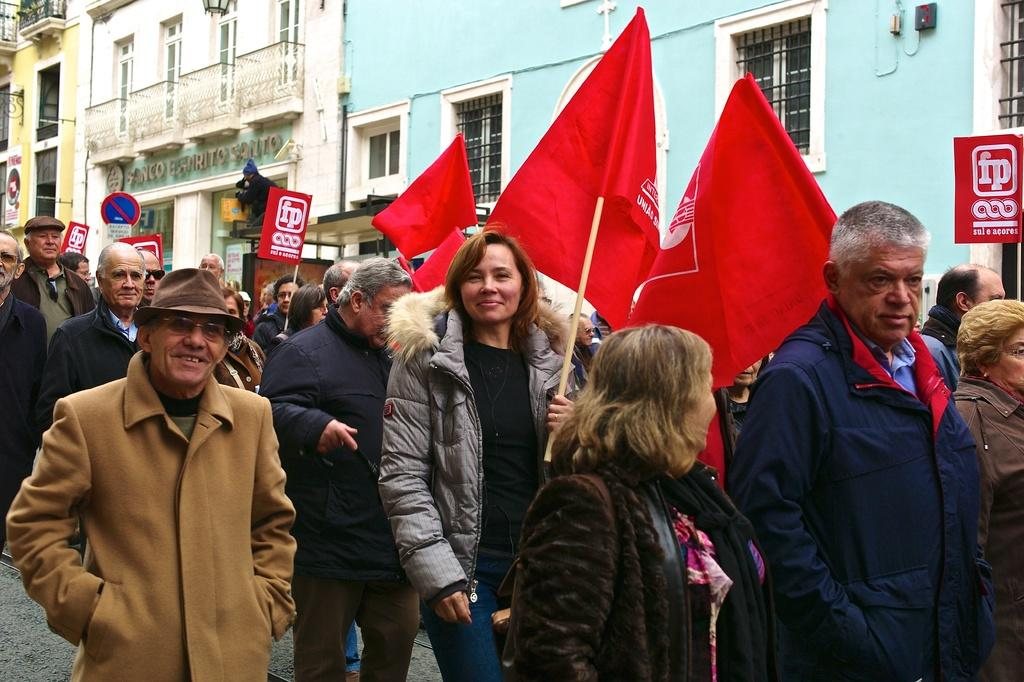What are the people in the image holding? The people in the image are holding flags and placards. What are the people doing in the image? The people are protesting on the street. What can be seen in the background of the image? There are buildings, a sign board, windows, and other objects visible in the background of the image. How many houses can be seen in the image? There are no houses visible in the image; it features people protesting on the street with buildings and other objects in the background. 